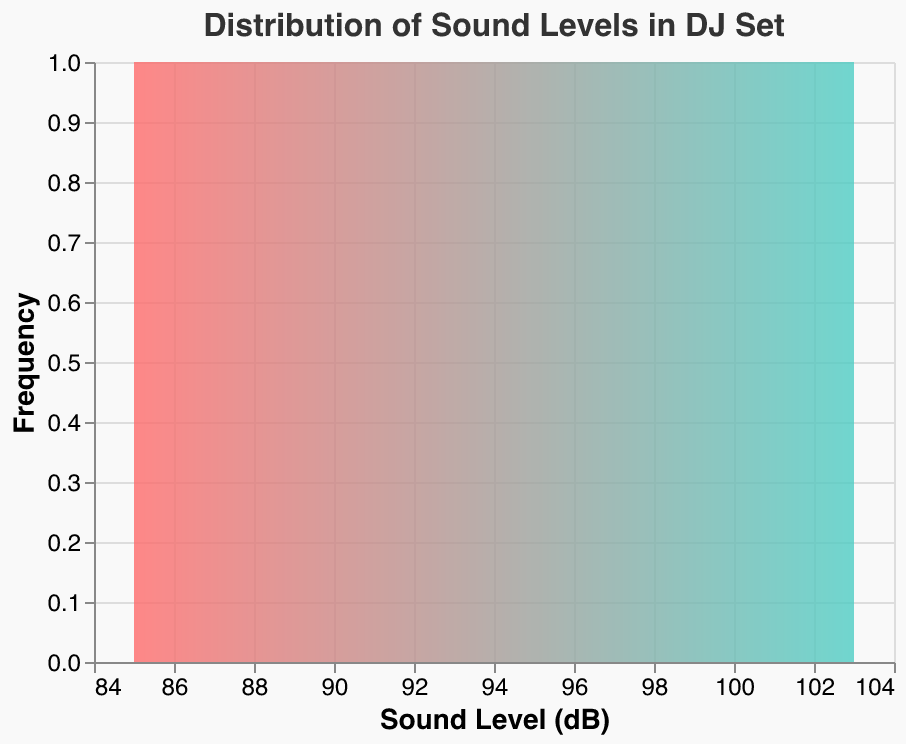What is the title of the figure? The title of the figure is usually found at the top center of the chart. This chart's title is clearly shown in the larger and bolder font compared to other texts.
Answer: Distribution of Sound Levels in DJ Set What is the color scheme of the area plot? The color scheme is represented by a linear gradient that transitions from one color to another. The scheme starts with a reddish color and transitions to a teal color.
Answer: From red to teal How many data points represent the sound levels? To find the number of data points, we look for the unique entries under "Time Interval" in the data. Counting these provides the total number.
Answer: 14 Which sound level has the highest frequency? The highest frequency will be the sound level where the area under the curve peaks the most. The y-axis, labeled "Frequency," helps in determining this. Since specific frequencies are not given, we rely on the visual prominence.
Answer: Around 90-95 dB What is the range of the sound levels recorded? The range is derived from the minimum and maximum values on the x-axis (Sound Level in dB). By observing the plot, we identify the smallest and largest values.
Answer: 85 dB to 103 dB What is the most frequent sound level range during the DJ set? By observing the area with the greatest frequency on the density plot, we can determine the range. The middle to high sound levels seem to have higher frequencies.
Answer: 88-92 dB What is the average sound level throughout the DJ set? To find the average, sum all the Sound Level (dB) values and divide by the number of data points. (This requires identifying and summing up the values before dividing by 14, the number of data points).
Answer: 93.36 dB Compare the peak sound levels between the "Mid Set Peak" and "Final Song Peak". Observing these two points' sound levels directly from their respective labels can show the peak values. The "Mid Set Peak" and "Final Song Peak" have different specific dB levels displayed next to each interval.
Answer: Mid Set Peak: 100 dB, Final Song Peak: 97 dB Which interval corresponds to the highest recorded sound level? The "Drop 1" and "Drop 2" intervals have the highest values. By checking which interval matches the maximum value in the figure (103 dB), you can identify the specific intervals.
Answer: Drop 2 What sound levels are least frequent throughout the DJ set? The least frequent sound levels are those that have the smallest area or no peak in their vicinity. On this plot, the edges, which means the lowest and highest dB ranges, are the least frequent areas.
Answer: 85-87 dB and 100-103 dB 